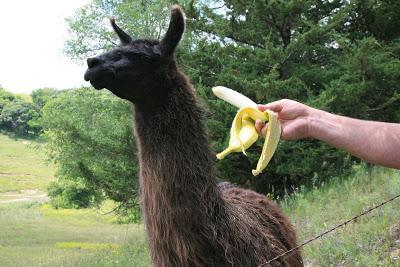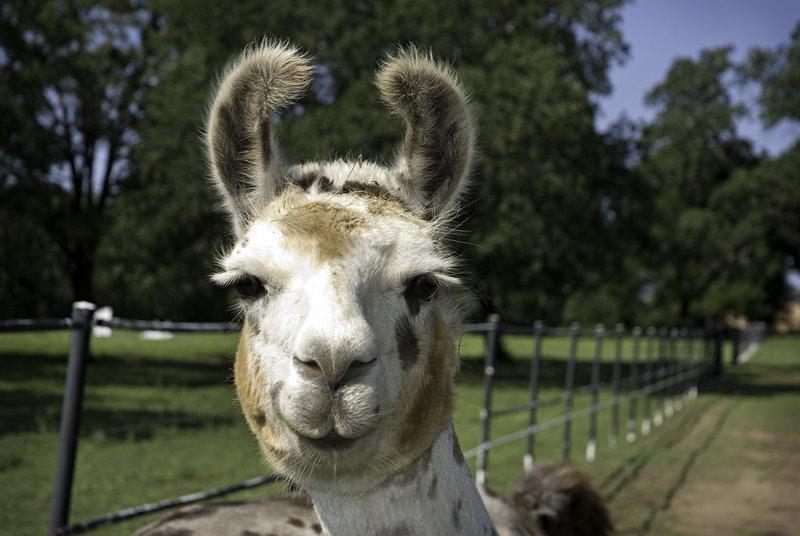The first image is the image on the left, the second image is the image on the right. Evaluate the accuracy of this statement regarding the images: "At least one llama is eating food.". Is it true? Answer yes or no. No. The first image is the image on the left, the second image is the image on the right. For the images shown, is this caption "An image contains a llama clenching something in its mouth." true? Answer yes or no. No. 